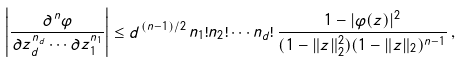Convert formula to latex. <formula><loc_0><loc_0><loc_500><loc_500>\left | \frac { \partial ^ { \, n } \varphi } { \partial z _ { d } ^ { n _ { d } } \cdots \partial z _ { 1 } ^ { n _ { 1 } } } \right | \leq d ^ { \, ( n - 1 ) / 2 } \, n _ { 1 } ! n _ { 2 } ! \cdots n _ { d } ! \, \frac { 1 - | \varphi ( z ) | ^ { 2 } } { ( 1 - \| z \| _ { 2 } ^ { 2 } ) ( 1 - \| z \| _ { 2 } ) ^ { n - 1 } } \, ,</formula> 